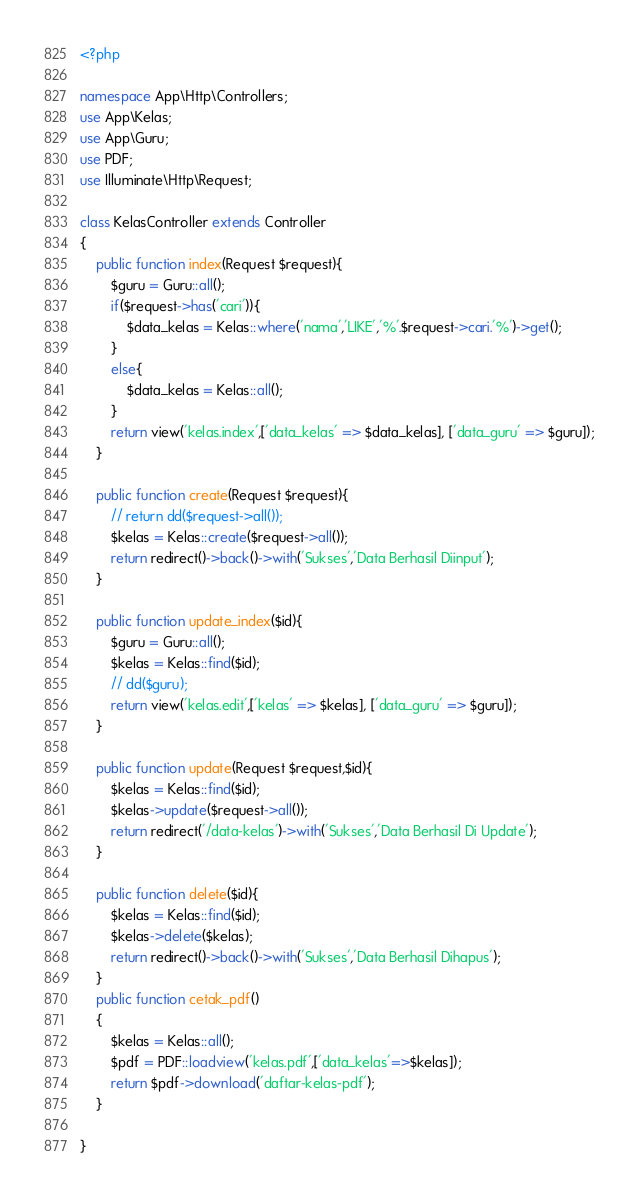<code> <loc_0><loc_0><loc_500><loc_500><_PHP_><?php

namespace App\Http\Controllers;
use App\Kelas;
use App\Guru;
use PDF;
use Illuminate\Http\Request;

class KelasController extends Controller
{
    public function index(Request $request){
        $guru = Guru::all();
        if($request->has('cari')){
            $data_kelas = Kelas::where('nama','LIKE','%'.$request->cari.'%')->get();
        }
        else{
            $data_kelas = Kelas::all();
        }
        return view('kelas.index',['data_kelas' => $data_kelas], ['data_guru' => $guru]);
    }

    public function create(Request $request){
        // return dd($request->all());
        $kelas = Kelas::create($request->all());
        return redirect()->back()->with('Sukses','Data Berhasil Diinput');
    }

    public function update_index($id){
        $guru = Guru::all();
        $kelas = Kelas::find($id);
        // dd($guru);
        return view('kelas.edit',['kelas' => $kelas], ['data_guru' => $guru]);
    }

    public function update(Request $request,$id){
        $kelas = Kelas::find($id);
        $kelas->update($request->all());
        return redirect('/data-kelas')->with('Sukses','Data Berhasil Di Update');
    }

    public function delete($id){
        $kelas = Kelas::find($id);
        $kelas->delete($kelas);
        return redirect()->back()->with('Sukses','Data Berhasil Dihapus');
    }
    public function cetak_pdf()
    {
    	$kelas = Kelas::all();
    	$pdf = PDF::loadview('kelas.pdf',['data_kelas'=>$kelas]);
    	return $pdf->download('daftar-kelas-pdf');
    }
    
}
</code> 